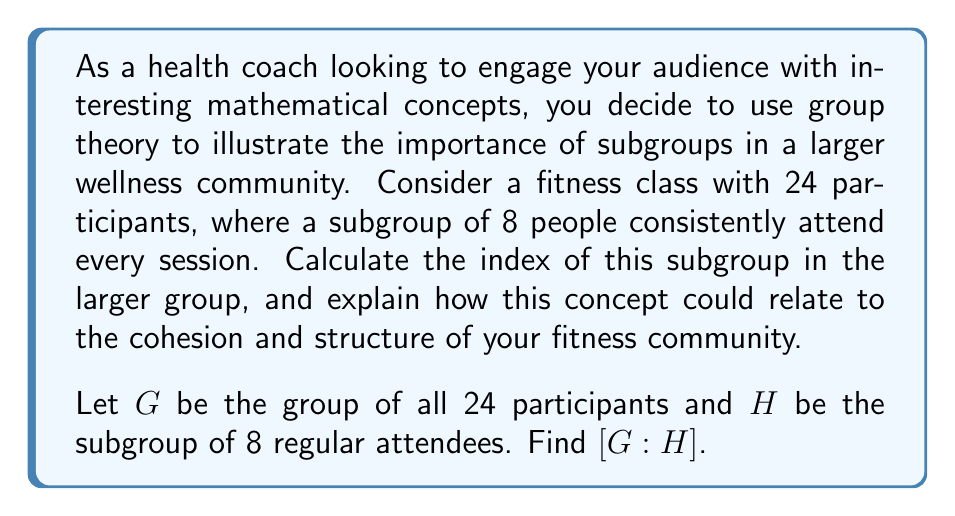What is the answer to this math problem? To calculate the index of a subgroup, we use the following steps:

1) The index of a subgroup $H$ in a group $G$, denoted $[G:H]$, is defined as the number of distinct left cosets of $H$ in $G$.

2) For finite groups, we can use the formula:

   $$[G:H] = \frac{|G|}{|H|}$$

   Where $|G|$ is the order (number of elements) of the larger group and $|H|$ is the order of the subgroup.

3) In this case:
   $|G| = 24$ (total participants)
   $|H| = 8$ (regular attendees)

4) Applying the formula:

   $$[G:H] = \frac{24}{8} = 3$$

5) Interpretation: This means there are 3 distinct cosets of $H$ in $G$. In the context of the fitness class, we can think of this as three "layers" or "categories" of participants based on their attendance patterns.

Relating to the fitness community:
- The index of 3 suggests that the class naturally divides into three attendance patterns.
- This could help in structuring the class, perhaps offering different levels of intensity or commitment.
- Understanding these subgroups can aid in tailoring communication and motivation strategies for different segments of the class.
Answer: $[G:H] = 3$ 